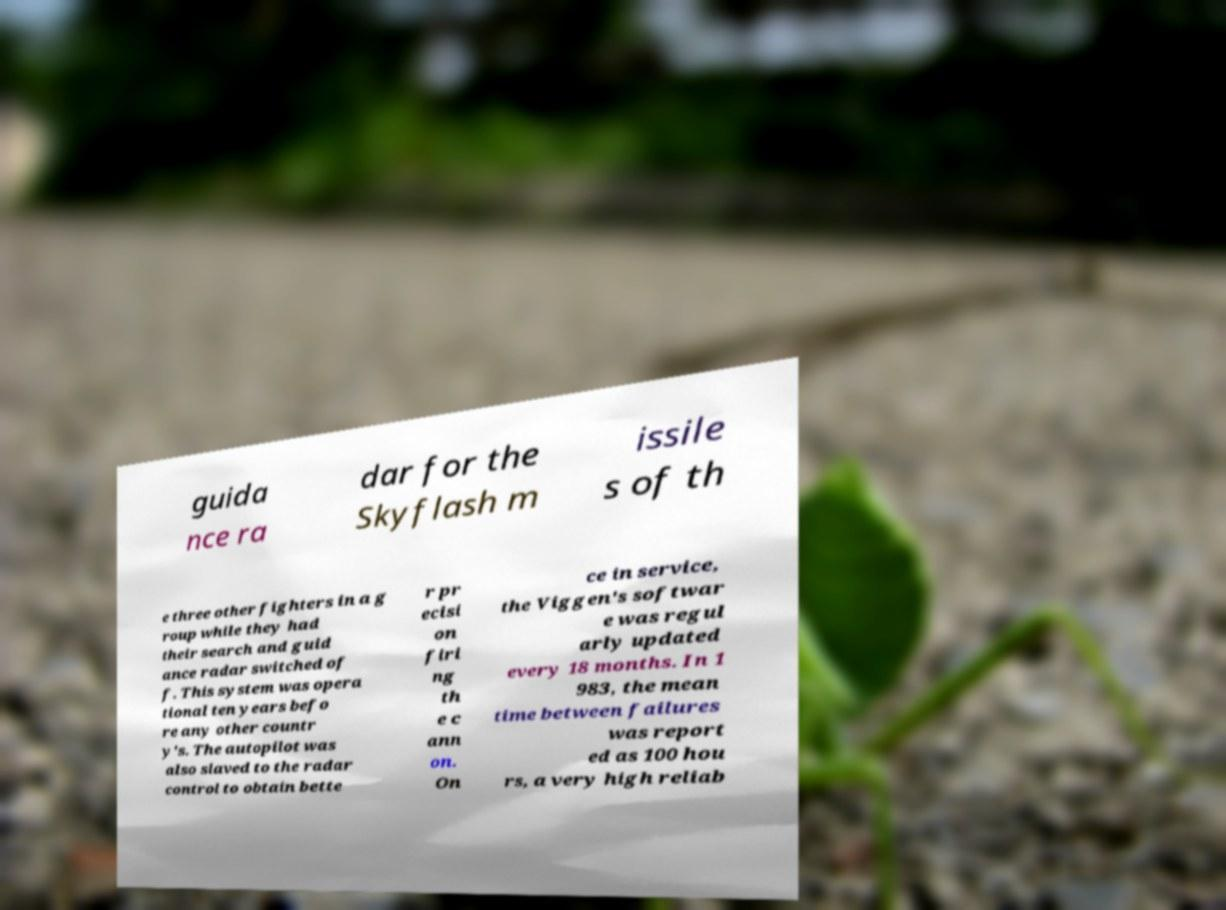For documentation purposes, I need the text within this image transcribed. Could you provide that? guida nce ra dar for the Skyflash m issile s of th e three other fighters in a g roup while they had their search and guid ance radar switched of f. This system was opera tional ten years befo re any other countr y's. The autopilot was also slaved to the radar control to obtain bette r pr ecisi on firi ng th e c ann on. On ce in service, the Viggen's softwar e was regul arly updated every 18 months. In 1 983, the mean time between failures was report ed as 100 hou rs, a very high reliab 